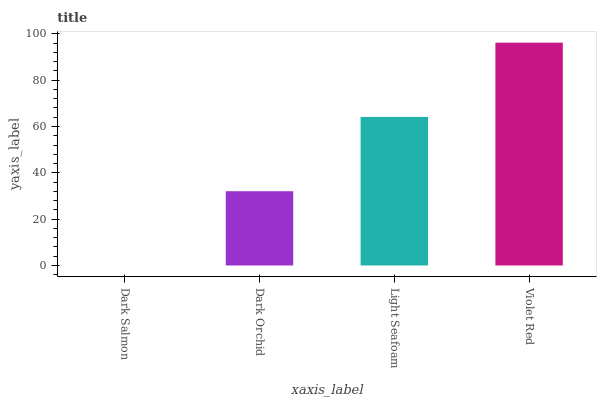Is Dark Salmon the minimum?
Answer yes or no. Yes. Is Violet Red the maximum?
Answer yes or no. Yes. Is Dark Orchid the minimum?
Answer yes or no. No. Is Dark Orchid the maximum?
Answer yes or no. No. Is Dark Orchid greater than Dark Salmon?
Answer yes or no. Yes. Is Dark Salmon less than Dark Orchid?
Answer yes or no. Yes. Is Dark Salmon greater than Dark Orchid?
Answer yes or no. No. Is Dark Orchid less than Dark Salmon?
Answer yes or no. No. Is Light Seafoam the high median?
Answer yes or no. Yes. Is Dark Orchid the low median?
Answer yes or no. Yes. Is Dark Orchid the high median?
Answer yes or no. No. Is Dark Salmon the low median?
Answer yes or no. No. 